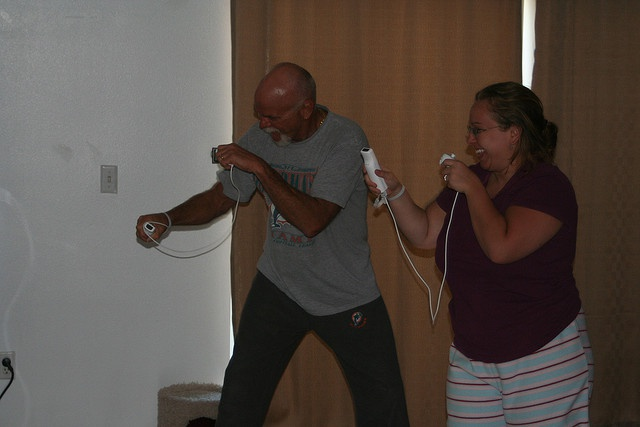Describe the objects in this image and their specific colors. I can see people in gray, black, and maroon tones, people in gray, black, and maroon tones, remote in gray and black tones, remote in gray and black tones, and remote in gray and black tones in this image. 